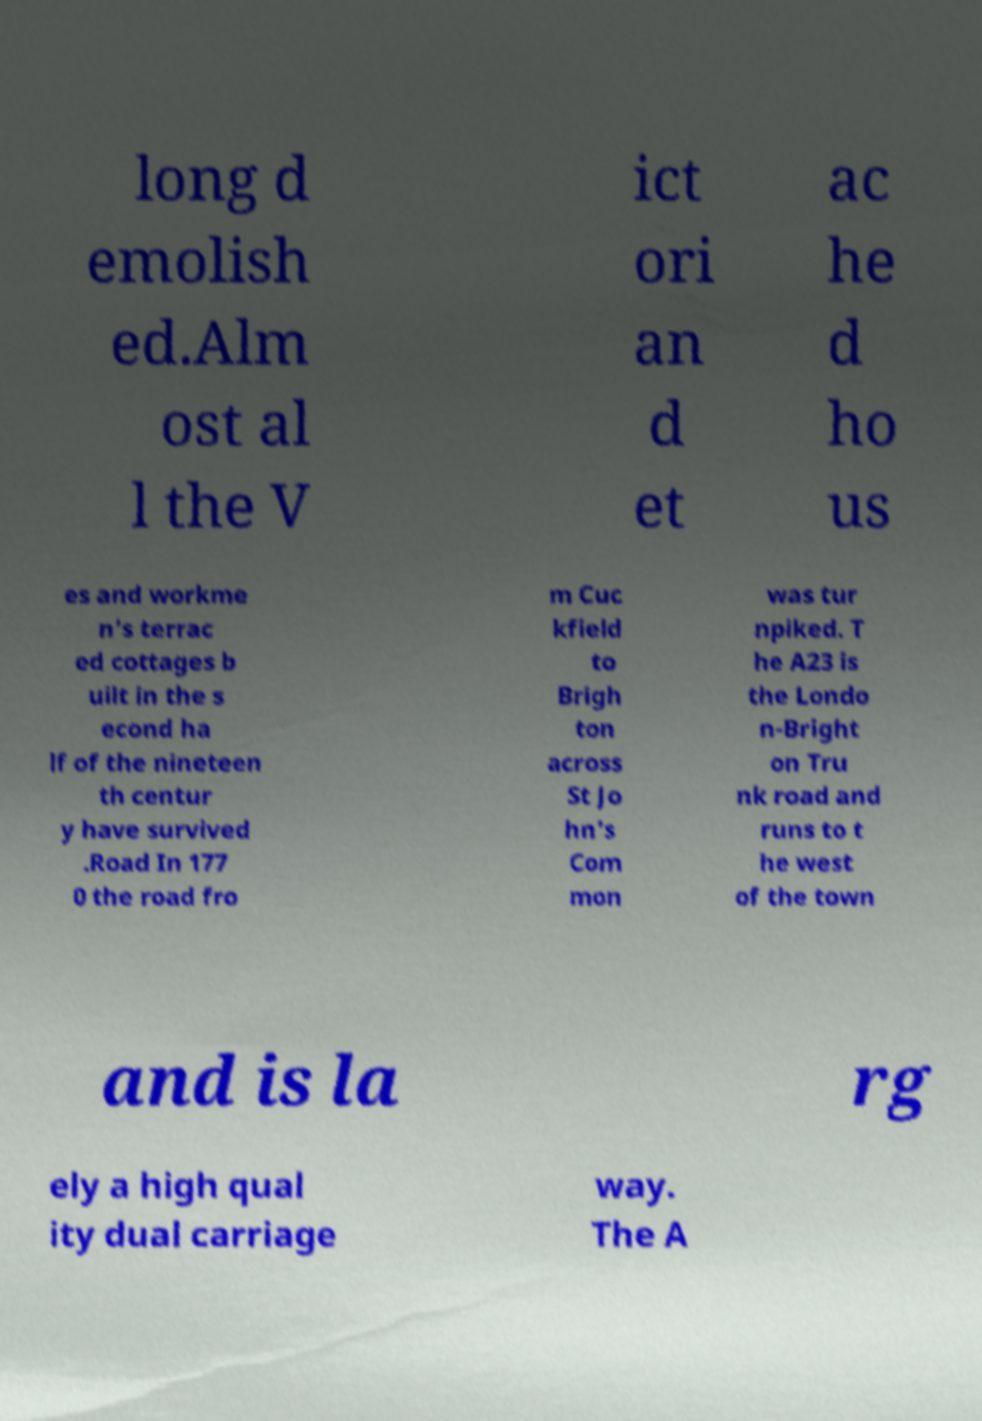Please identify and transcribe the text found in this image. long d emolish ed.Alm ost al l the V ict ori an d et ac he d ho us es and workme n's terrac ed cottages b uilt in the s econd ha lf of the nineteen th centur y have survived .Road In 177 0 the road fro m Cuc kfield to Brigh ton across St Jo hn's Com mon was tur npiked. T he A23 is the Londo n-Bright on Tru nk road and runs to t he west of the town and is la rg ely a high qual ity dual carriage way. The A 